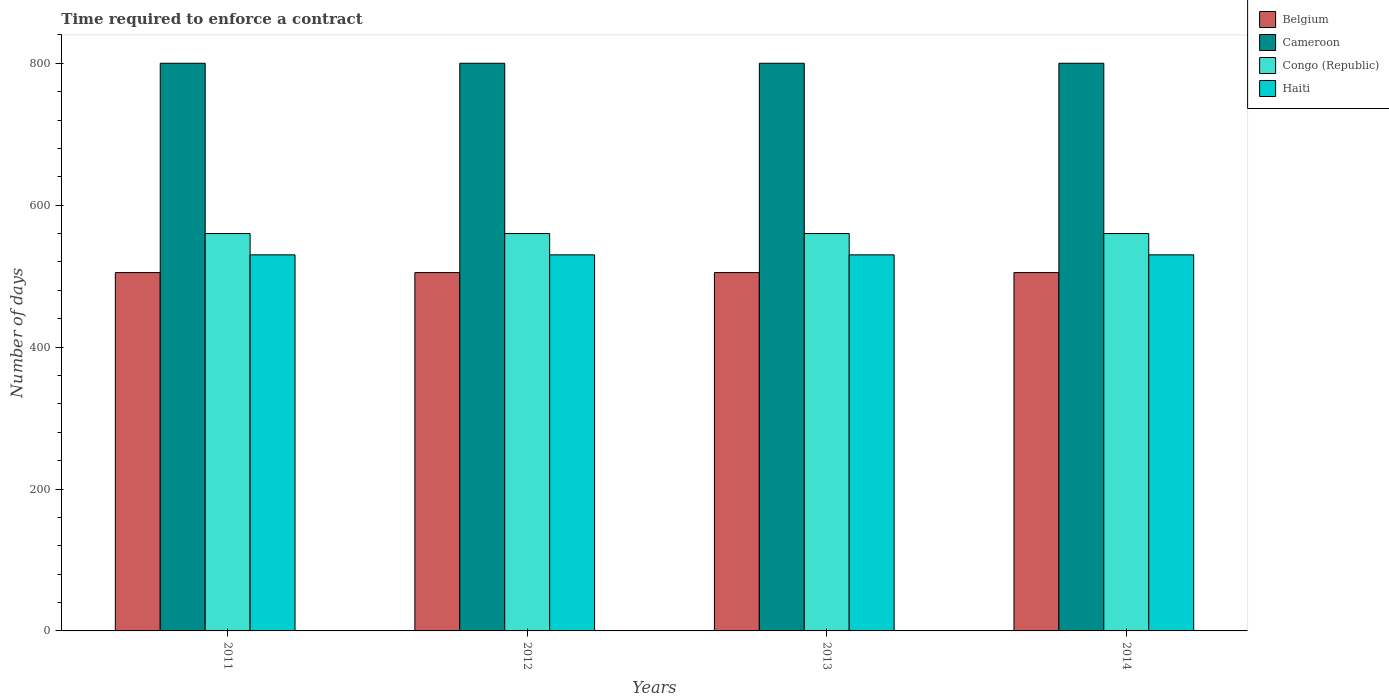How many groups of bars are there?
Keep it short and to the point. 4. Are the number of bars per tick equal to the number of legend labels?
Make the answer very short. Yes. In how many cases, is the number of bars for a given year not equal to the number of legend labels?
Keep it short and to the point. 0. What is the number of days required to enforce a contract in Congo (Republic) in 2014?
Offer a very short reply. 560. Across all years, what is the maximum number of days required to enforce a contract in Cameroon?
Your answer should be compact. 800. Across all years, what is the minimum number of days required to enforce a contract in Cameroon?
Your answer should be very brief. 800. What is the total number of days required to enforce a contract in Haiti in the graph?
Ensure brevity in your answer.  2120. What is the difference between the number of days required to enforce a contract in Belgium in 2011 and the number of days required to enforce a contract in Cameroon in 2013?
Make the answer very short. -295. What is the average number of days required to enforce a contract in Haiti per year?
Your answer should be very brief. 530. In the year 2012, what is the difference between the number of days required to enforce a contract in Congo (Republic) and number of days required to enforce a contract in Cameroon?
Your answer should be very brief. -240. What is the ratio of the number of days required to enforce a contract in Haiti in 2012 to that in 2014?
Your response must be concise. 1. Is the number of days required to enforce a contract in Congo (Republic) in 2011 less than that in 2013?
Your answer should be very brief. No. Is the difference between the number of days required to enforce a contract in Congo (Republic) in 2012 and 2013 greater than the difference between the number of days required to enforce a contract in Cameroon in 2012 and 2013?
Provide a short and direct response. No. What is the difference between the highest and the second highest number of days required to enforce a contract in Belgium?
Offer a terse response. 0. In how many years, is the number of days required to enforce a contract in Cameroon greater than the average number of days required to enforce a contract in Cameroon taken over all years?
Offer a terse response. 0. Is the sum of the number of days required to enforce a contract in Congo (Republic) in 2011 and 2013 greater than the maximum number of days required to enforce a contract in Belgium across all years?
Offer a terse response. Yes. Is it the case that in every year, the sum of the number of days required to enforce a contract in Cameroon and number of days required to enforce a contract in Belgium is greater than the sum of number of days required to enforce a contract in Congo (Republic) and number of days required to enforce a contract in Haiti?
Your response must be concise. No. What does the 3rd bar from the left in 2011 represents?
Provide a short and direct response. Congo (Republic). What does the 3rd bar from the right in 2013 represents?
Give a very brief answer. Cameroon. Is it the case that in every year, the sum of the number of days required to enforce a contract in Haiti and number of days required to enforce a contract in Belgium is greater than the number of days required to enforce a contract in Congo (Republic)?
Give a very brief answer. Yes. How many bars are there?
Your answer should be compact. 16. What is the difference between two consecutive major ticks on the Y-axis?
Give a very brief answer. 200. Does the graph contain grids?
Keep it short and to the point. No. What is the title of the graph?
Your answer should be compact. Time required to enforce a contract. Does "Switzerland" appear as one of the legend labels in the graph?
Your response must be concise. No. What is the label or title of the X-axis?
Offer a very short reply. Years. What is the label or title of the Y-axis?
Provide a succinct answer. Number of days. What is the Number of days of Belgium in 2011?
Provide a short and direct response. 505. What is the Number of days in Cameroon in 2011?
Give a very brief answer. 800. What is the Number of days in Congo (Republic) in 2011?
Offer a very short reply. 560. What is the Number of days in Haiti in 2011?
Give a very brief answer. 530. What is the Number of days of Belgium in 2012?
Keep it short and to the point. 505. What is the Number of days in Cameroon in 2012?
Your answer should be very brief. 800. What is the Number of days of Congo (Republic) in 2012?
Make the answer very short. 560. What is the Number of days of Haiti in 2012?
Keep it short and to the point. 530. What is the Number of days in Belgium in 2013?
Make the answer very short. 505. What is the Number of days in Cameroon in 2013?
Provide a short and direct response. 800. What is the Number of days of Congo (Republic) in 2013?
Offer a terse response. 560. What is the Number of days in Haiti in 2013?
Your answer should be compact. 530. What is the Number of days of Belgium in 2014?
Provide a short and direct response. 505. What is the Number of days in Cameroon in 2014?
Offer a very short reply. 800. What is the Number of days in Congo (Republic) in 2014?
Your answer should be very brief. 560. What is the Number of days in Haiti in 2014?
Keep it short and to the point. 530. Across all years, what is the maximum Number of days in Belgium?
Provide a succinct answer. 505. Across all years, what is the maximum Number of days in Cameroon?
Make the answer very short. 800. Across all years, what is the maximum Number of days of Congo (Republic)?
Your answer should be compact. 560. Across all years, what is the maximum Number of days in Haiti?
Your answer should be very brief. 530. Across all years, what is the minimum Number of days of Belgium?
Keep it short and to the point. 505. Across all years, what is the minimum Number of days of Cameroon?
Your response must be concise. 800. Across all years, what is the minimum Number of days in Congo (Republic)?
Give a very brief answer. 560. Across all years, what is the minimum Number of days of Haiti?
Keep it short and to the point. 530. What is the total Number of days in Belgium in the graph?
Provide a short and direct response. 2020. What is the total Number of days in Cameroon in the graph?
Your answer should be compact. 3200. What is the total Number of days of Congo (Republic) in the graph?
Your answer should be compact. 2240. What is the total Number of days in Haiti in the graph?
Offer a very short reply. 2120. What is the difference between the Number of days of Belgium in 2011 and that in 2012?
Provide a short and direct response. 0. What is the difference between the Number of days of Cameroon in 2011 and that in 2012?
Ensure brevity in your answer.  0. What is the difference between the Number of days of Congo (Republic) in 2011 and that in 2012?
Provide a short and direct response. 0. What is the difference between the Number of days in Haiti in 2011 and that in 2012?
Provide a short and direct response. 0. What is the difference between the Number of days of Belgium in 2011 and that in 2013?
Offer a terse response. 0. What is the difference between the Number of days of Cameroon in 2011 and that in 2013?
Provide a succinct answer. 0. What is the difference between the Number of days in Congo (Republic) in 2011 and that in 2013?
Keep it short and to the point. 0. What is the difference between the Number of days in Haiti in 2011 and that in 2013?
Your answer should be very brief. 0. What is the difference between the Number of days in Belgium in 2012 and that in 2013?
Provide a succinct answer. 0. What is the difference between the Number of days in Cameroon in 2012 and that in 2013?
Provide a succinct answer. 0. What is the difference between the Number of days in Haiti in 2012 and that in 2013?
Offer a very short reply. 0. What is the difference between the Number of days of Belgium in 2012 and that in 2014?
Provide a succinct answer. 0. What is the difference between the Number of days in Cameroon in 2012 and that in 2014?
Keep it short and to the point. 0. What is the difference between the Number of days of Cameroon in 2013 and that in 2014?
Provide a short and direct response. 0. What is the difference between the Number of days of Congo (Republic) in 2013 and that in 2014?
Offer a very short reply. 0. What is the difference between the Number of days in Haiti in 2013 and that in 2014?
Keep it short and to the point. 0. What is the difference between the Number of days of Belgium in 2011 and the Number of days of Cameroon in 2012?
Keep it short and to the point. -295. What is the difference between the Number of days of Belgium in 2011 and the Number of days of Congo (Republic) in 2012?
Your response must be concise. -55. What is the difference between the Number of days in Cameroon in 2011 and the Number of days in Congo (Republic) in 2012?
Ensure brevity in your answer.  240. What is the difference between the Number of days in Cameroon in 2011 and the Number of days in Haiti in 2012?
Offer a terse response. 270. What is the difference between the Number of days of Belgium in 2011 and the Number of days of Cameroon in 2013?
Make the answer very short. -295. What is the difference between the Number of days in Belgium in 2011 and the Number of days in Congo (Republic) in 2013?
Provide a succinct answer. -55. What is the difference between the Number of days of Belgium in 2011 and the Number of days of Haiti in 2013?
Your response must be concise. -25. What is the difference between the Number of days in Cameroon in 2011 and the Number of days in Congo (Republic) in 2013?
Your response must be concise. 240. What is the difference between the Number of days of Cameroon in 2011 and the Number of days of Haiti in 2013?
Provide a short and direct response. 270. What is the difference between the Number of days of Belgium in 2011 and the Number of days of Cameroon in 2014?
Provide a succinct answer. -295. What is the difference between the Number of days of Belgium in 2011 and the Number of days of Congo (Republic) in 2014?
Your answer should be very brief. -55. What is the difference between the Number of days in Cameroon in 2011 and the Number of days in Congo (Republic) in 2014?
Provide a short and direct response. 240. What is the difference between the Number of days in Cameroon in 2011 and the Number of days in Haiti in 2014?
Offer a terse response. 270. What is the difference between the Number of days in Belgium in 2012 and the Number of days in Cameroon in 2013?
Offer a very short reply. -295. What is the difference between the Number of days of Belgium in 2012 and the Number of days of Congo (Republic) in 2013?
Your answer should be compact. -55. What is the difference between the Number of days of Belgium in 2012 and the Number of days of Haiti in 2013?
Ensure brevity in your answer.  -25. What is the difference between the Number of days in Cameroon in 2012 and the Number of days in Congo (Republic) in 2013?
Offer a very short reply. 240. What is the difference between the Number of days of Cameroon in 2012 and the Number of days of Haiti in 2013?
Provide a short and direct response. 270. What is the difference between the Number of days in Congo (Republic) in 2012 and the Number of days in Haiti in 2013?
Your response must be concise. 30. What is the difference between the Number of days of Belgium in 2012 and the Number of days of Cameroon in 2014?
Ensure brevity in your answer.  -295. What is the difference between the Number of days of Belgium in 2012 and the Number of days of Congo (Republic) in 2014?
Your answer should be very brief. -55. What is the difference between the Number of days in Belgium in 2012 and the Number of days in Haiti in 2014?
Make the answer very short. -25. What is the difference between the Number of days of Cameroon in 2012 and the Number of days of Congo (Republic) in 2014?
Your answer should be compact. 240. What is the difference between the Number of days in Cameroon in 2012 and the Number of days in Haiti in 2014?
Provide a succinct answer. 270. What is the difference between the Number of days in Belgium in 2013 and the Number of days in Cameroon in 2014?
Ensure brevity in your answer.  -295. What is the difference between the Number of days of Belgium in 2013 and the Number of days of Congo (Republic) in 2014?
Provide a short and direct response. -55. What is the difference between the Number of days of Belgium in 2013 and the Number of days of Haiti in 2014?
Your response must be concise. -25. What is the difference between the Number of days of Cameroon in 2013 and the Number of days of Congo (Republic) in 2014?
Give a very brief answer. 240. What is the difference between the Number of days in Cameroon in 2013 and the Number of days in Haiti in 2014?
Make the answer very short. 270. What is the difference between the Number of days in Congo (Republic) in 2013 and the Number of days in Haiti in 2014?
Ensure brevity in your answer.  30. What is the average Number of days of Belgium per year?
Offer a terse response. 505. What is the average Number of days of Cameroon per year?
Keep it short and to the point. 800. What is the average Number of days in Congo (Republic) per year?
Give a very brief answer. 560. What is the average Number of days of Haiti per year?
Provide a succinct answer. 530. In the year 2011, what is the difference between the Number of days of Belgium and Number of days of Cameroon?
Ensure brevity in your answer.  -295. In the year 2011, what is the difference between the Number of days of Belgium and Number of days of Congo (Republic)?
Provide a succinct answer. -55. In the year 2011, what is the difference between the Number of days of Belgium and Number of days of Haiti?
Your answer should be very brief. -25. In the year 2011, what is the difference between the Number of days in Cameroon and Number of days in Congo (Republic)?
Your answer should be very brief. 240. In the year 2011, what is the difference between the Number of days of Cameroon and Number of days of Haiti?
Ensure brevity in your answer.  270. In the year 2012, what is the difference between the Number of days of Belgium and Number of days of Cameroon?
Make the answer very short. -295. In the year 2012, what is the difference between the Number of days in Belgium and Number of days in Congo (Republic)?
Give a very brief answer. -55. In the year 2012, what is the difference between the Number of days in Cameroon and Number of days in Congo (Republic)?
Your answer should be very brief. 240. In the year 2012, what is the difference between the Number of days in Cameroon and Number of days in Haiti?
Your answer should be very brief. 270. In the year 2012, what is the difference between the Number of days in Congo (Republic) and Number of days in Haiti?
Your response must be concise. 30. In the year 2013, what is the difference between the Number of days of Belgium and Number of days of Cameroon?
Provide a short and direct response. -295. In the year 2013, what is the difference between the Number of days in Belgium and Number of days in Congo (Republic)?
Offer a very short reply. -55. In the year 2013, what is the difference between the Number of days of Cameroon and Number of days of Congo (Republic)?
Ensure brevity in your answer.  240. In the year 2013, what is the difference between the Number of days of Cameroon and Number of days of Haiti?
Provide a short and direct response. 270. In the year 2014, what is the difference between the Number of days of Belgium and Number of days of Cameroon?
Keep it short and to the point. -295. In the year 2014, what is the difference between the Number of days in Belgium and Number of days in Congo (Republic)?
Your answer should be very brief. -55. In the year 2014, what is the difference between the Number of days of Cameroon and Number of days of Congo (Republic)?
Make the answer very short. 240. In the year 2014, what is the difference between the Number of days in Cameroon and Number of days in Haiti?
Ensure brevity in your answer.  270. What is the ratio of the Number of days in Belgium in 2011 to that in 2012?
Give a very brief answer. 1. What is the ratio of the Number of days of Congo (Republic) in 2011 to that in 2012?
Offer a very short reply. 1. What is the ratio of the Number of days in Haiti in 2011 to that in 2012?
Give a very brief answer. 1. What is the ratio of the Number of days in Belgium in 2011 to that in 2013?
Offer a terse response. 1. What is the ratio of the Number of days of Cameroon in 2011 to that in 2013?
Your answer should be compact. 1. What is the ratio of the Number of days of Congo (Republic) in 2011 to that in 2013?
Your response must be concise. 1. What is the ratio of the Number of days in Haiti in 2011 to that in 2013?
Offer a very short reply. 1. What is the ratio of the Number of days in Belgium in 2011 to that in 2014?
Provide a succinct answer. 1. What is the ratio of the Number of days of Cameroon in 2011 to that in 2014?
Offer a very short reply. 1. What is the ratio of the Number of days of Congo (Republic) in 2011 to that in 2014?
Give a very brief answer. 1. What is the ratio of the Number of days in Cameroon in 2012 to that in 2013?
Provide a short and direct response. 1. What is the ratio of the Number of days of Congo (Republic) in 2012 to that in 2013?
Ensure brevity in your answer.  1. What is the ratio of the Number of days in Haiti in 2012 to that in 2013?
Make the answer very short. 1. What is the ratio of the Number of days of Belgium in 2012 to that in 2014?
Your response must be concise. 1. What is the ratio of the Number of days in Cameroon in 2013 to that in 2014?
Give a very brief answer. 1. What is the difference between the highest and the second highest Number of days in Belgium?
Your answer should be very brief. 0. What is the difference between the highest and the second highest Number of days in Cameroon?
Keep it short and to the point. 0. What is the difference between the highest and the second highest Number of days of Haiti?
Make the answer very short. 0. What is the difference between the highest and the lowest Number of days of Cameroon?
Give a very brief answer. 0. 